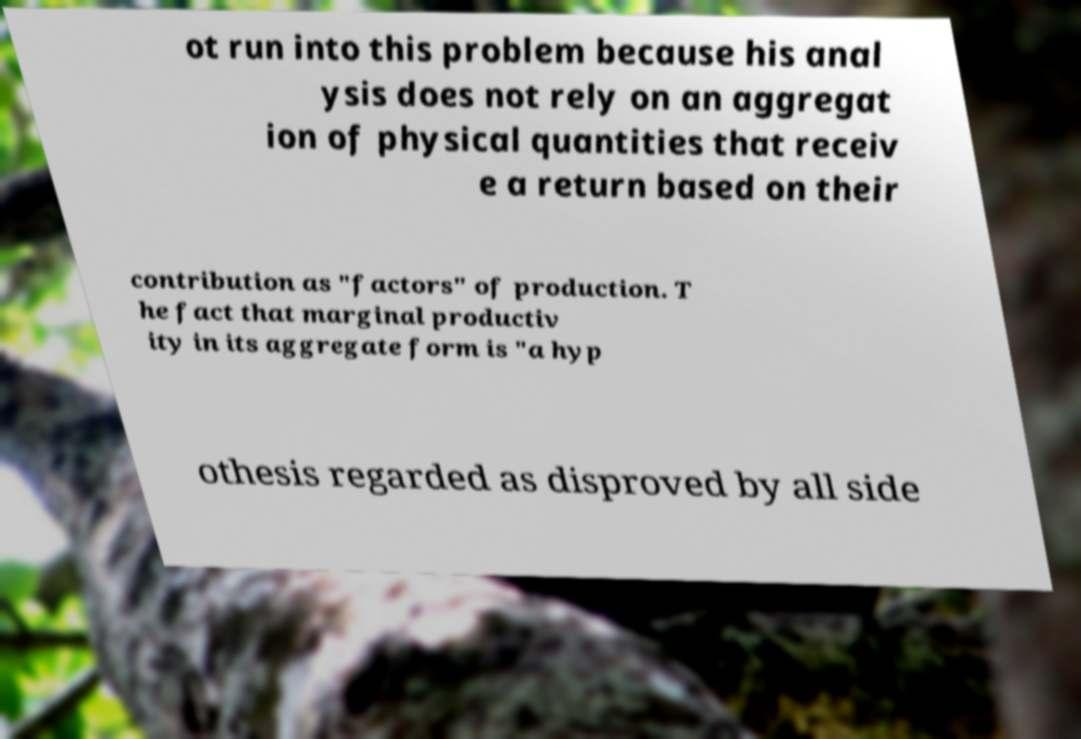Could you assist in decoding the text presented in this image and type it out clearly? ot run into this problem because his anal ysis does not rely on an aggregat ion of physical quantities that receiv e a return based on their contribution as "factors" of production. T he fact that marginal productiv ity in its aggregate form is "a hyp othesis regarded as disproved by all side 